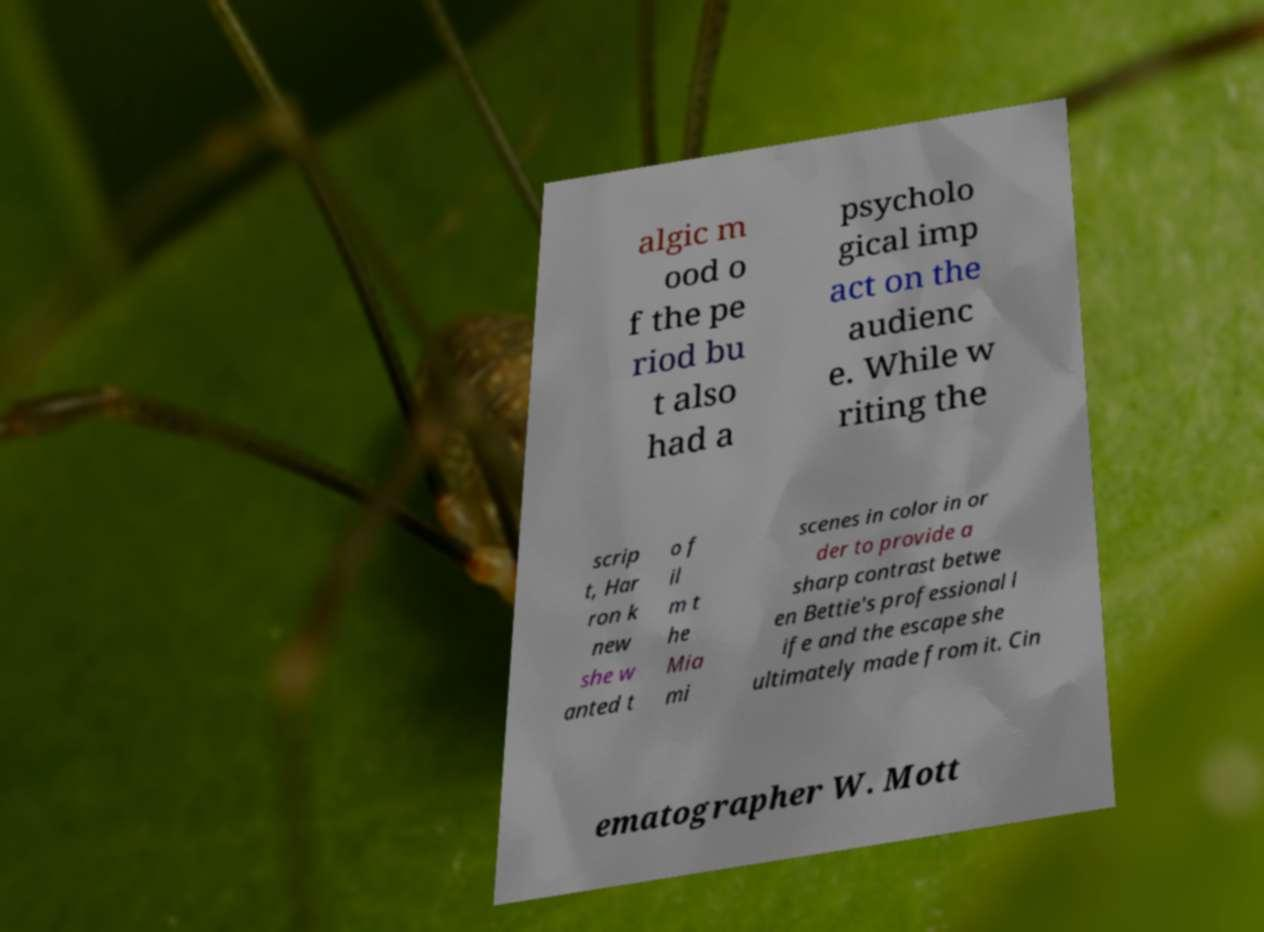There's text embedded in this image that I need extracted. Can you transcribe it verbatim? algic m ood o f the pe riod bu t also had a psycholo gical imp act on the audienc e. While w riting the scrip t, Har ron k new she w anted t o f il m t he Mia mi scenes in color in or der to provide a sharp contrast betwe en Bettie's professional l ife and the escape she ultimately made from it. Cin ematographer W. Mott 